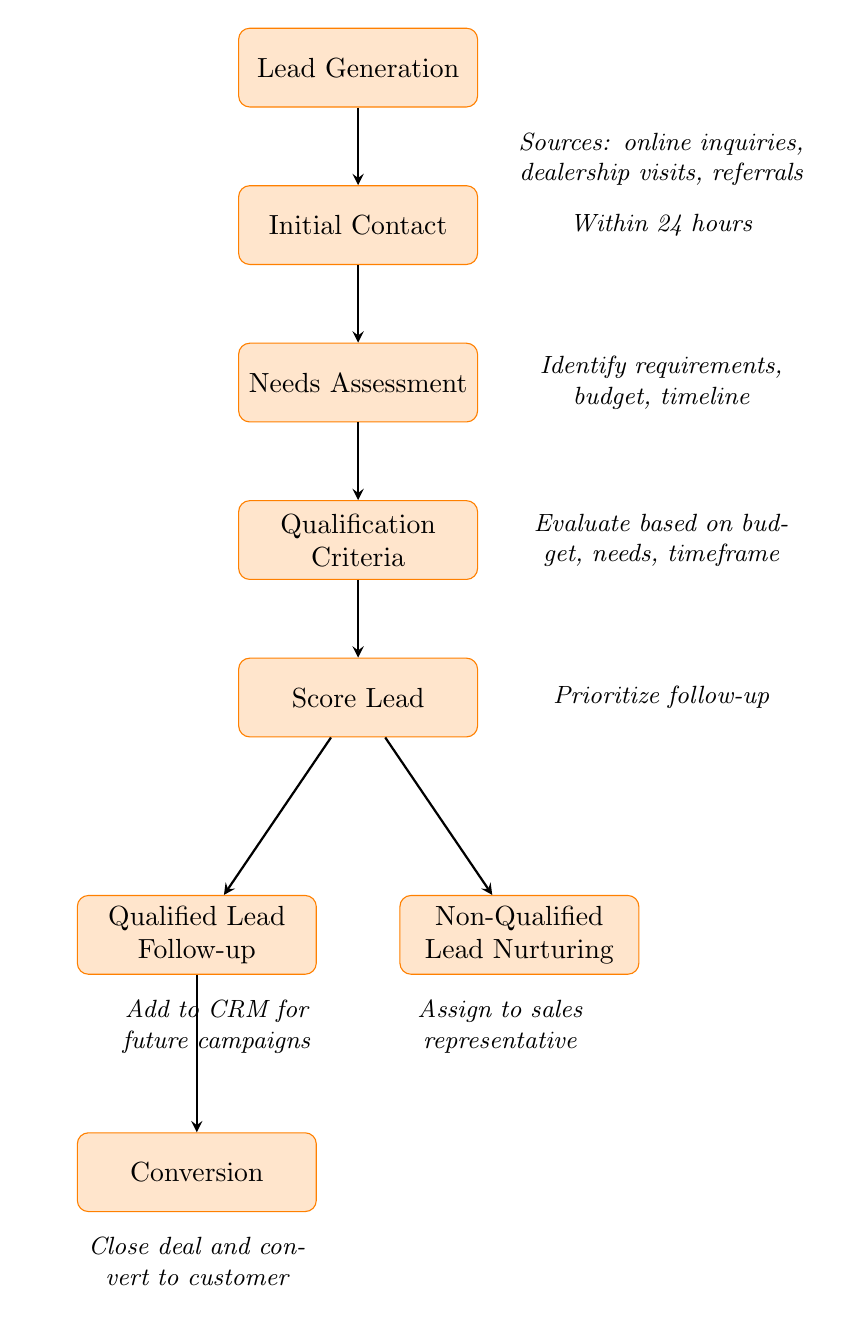What is the first step in the customer lead qualification process? The first step in the diagram is "Lead Generation", which is the starting point of the process.
Answer: Lead Generation How many nodes are present in the diagram? By counting each labeled process represented in the diagram, there are a total of 8 distinct nodes.
Answer: 8 Which node comes after "Needs Assessment"? Following the "Needs Assessment" node, the next step in the flow is "Qualification Criteria", which is directly below it in the diagram.
Answer: Qualification Criteria What happens to non-qualified leads? Non-qualified leads are directed towards "Non-Qualified Lead Nurturing", indicating that they are added to the CRM for future marketing campaigns.
Answer: Non-Qualified Lead Nurturing What is the outcome of "Score Lead"? The "Score Lead" process leads to two different outcomes: the qualified leads proceed to "Qualified Lead Follow-up" while the non-qualified leads go to "Non-Qualified Lead Nurturing".
Answer: Qualified Lead Follow-up and Non-Qualified Lead Nurturing Which step involves contacting the lead? The step where the sales representative contacts the lead is labeled "Initial Contact", which comes directly after Lead Generation.
Answer: Initial Contact What is identified during the "Needs Assessment" phase? In the "Needs Assessment" phase, customer requirements, budget, and timeline are identified, indicating a comprehensive understanding of what the customer needs.
Answer: Customer requirements, budget, and timeline What is the final outcome of a qualified lead? The final outcome of a qualified lead in the process is represented by the node "Conversion", which signifies that the lead is successfully closed as a deal and becomes a customer.
Answer: Conversion 